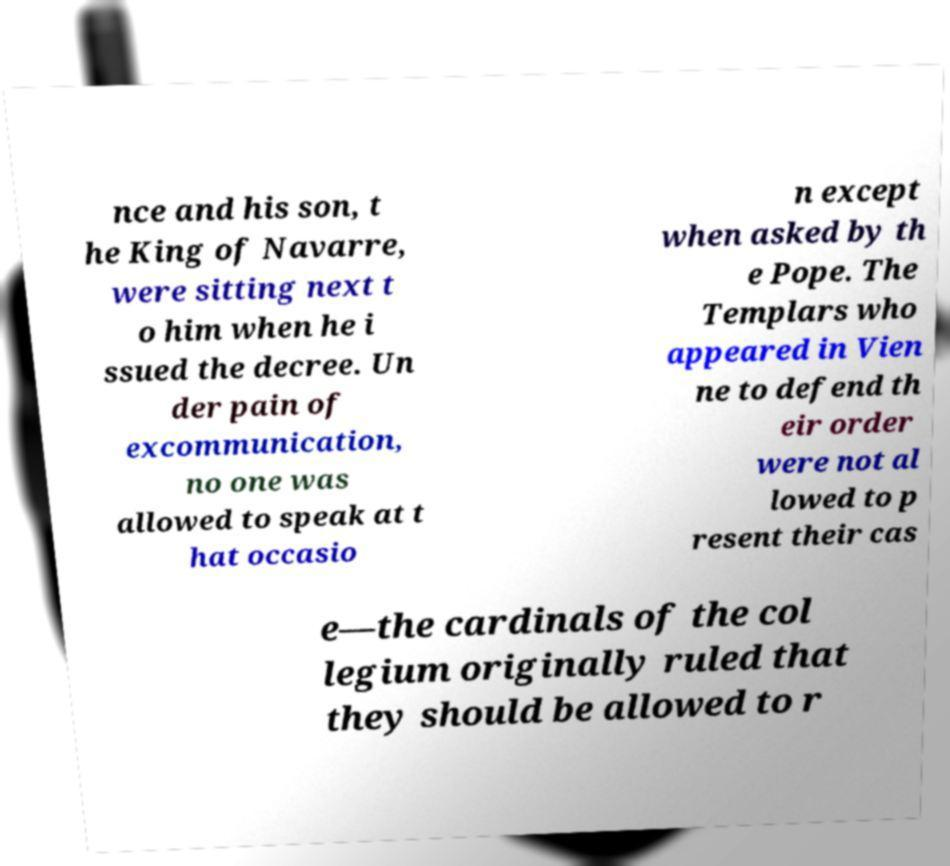I need the written content from this picture converted into text. Can you do that? nce and his son, t he King of Navarre, were sitting next t o him when he i ssued the decree. Un der pain of excommunication, no one was allowed to speak at t hat occasio n except when asked by th e Pope. The Templars who appeared in Vien ne to defend th eir order were not al lowed to p resent their cas e—the cardinals of the col legium originally ruled that they should be allowed to r 